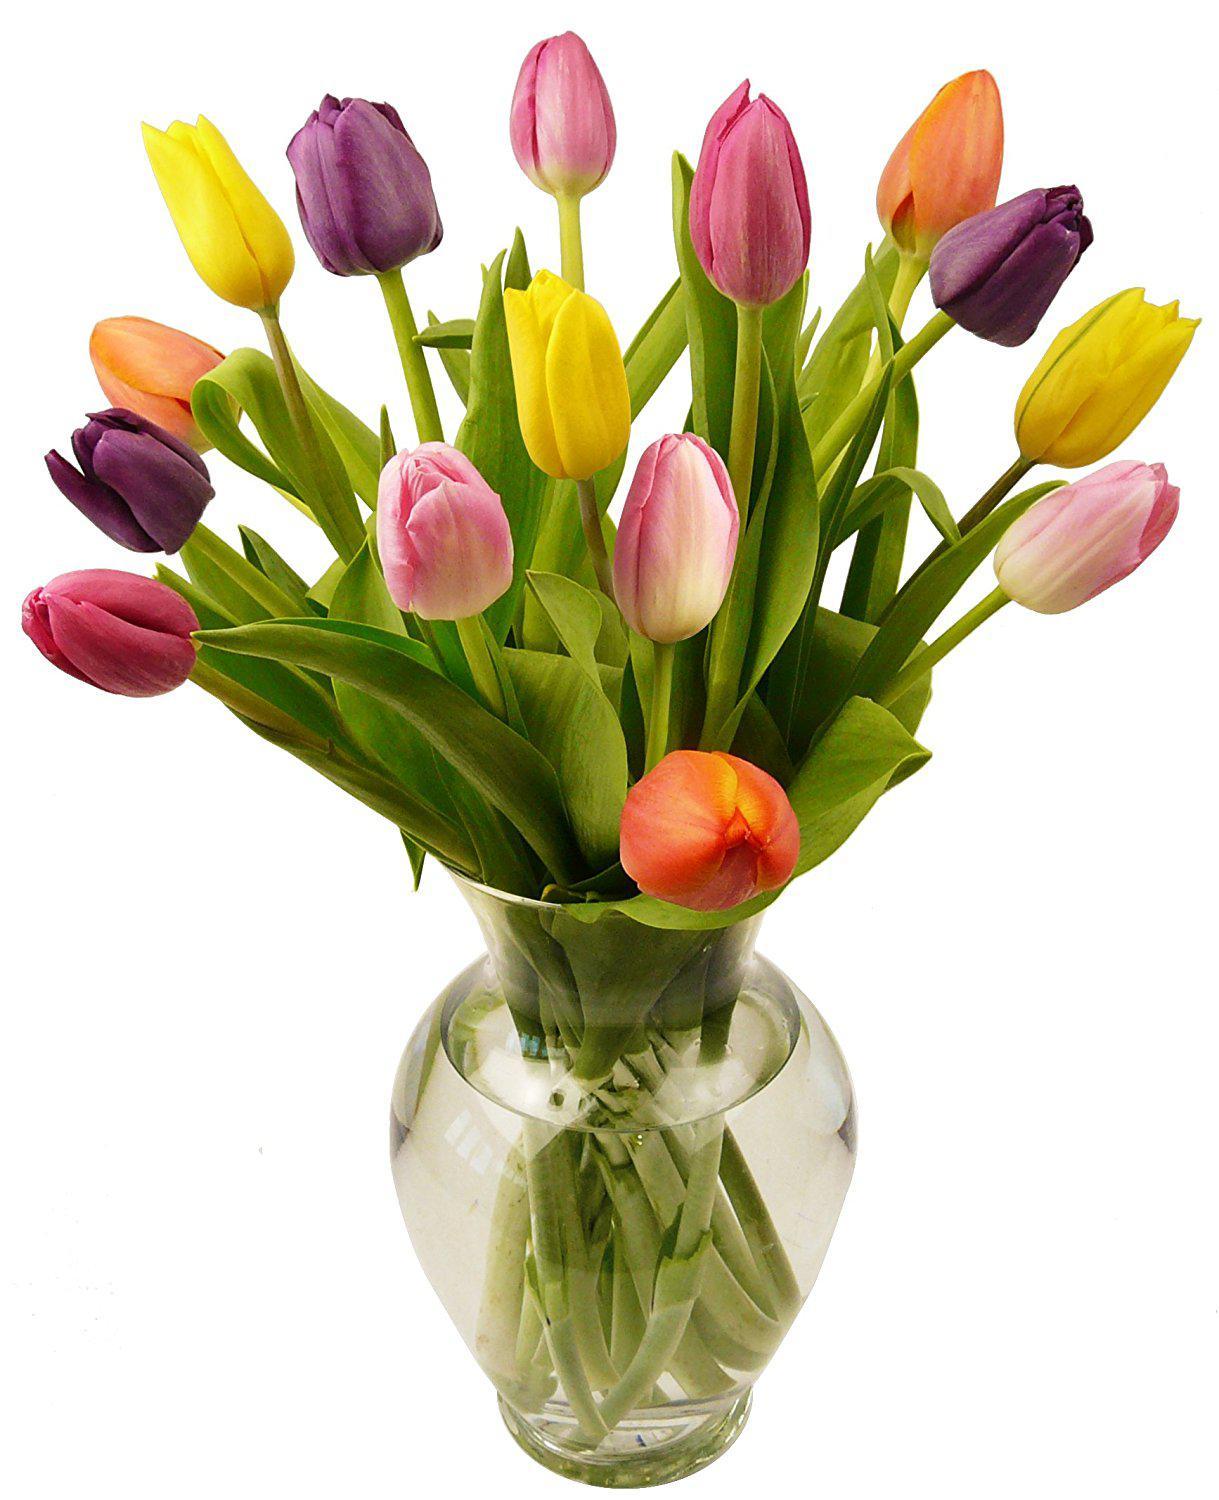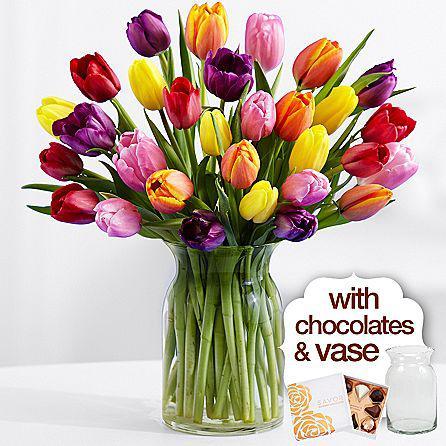The first image is the image on the left, the second image is the image on the right. Assess this claim about the two images: "Each of two vases of multicolored tulips is clear so that the green flower stems are visible, and contains at least three yellow flowers.". Correct or not? Answer yes or no. Yes. The first image is the image on the left, the second image is the image on the right. Evaluate the accuracy of this statement regarding the images: "Each image features multicolor tulips in a clear glass vase, and one of the vases has a rather spherical shape.". Is it true? Answer yes or no. Yes. 